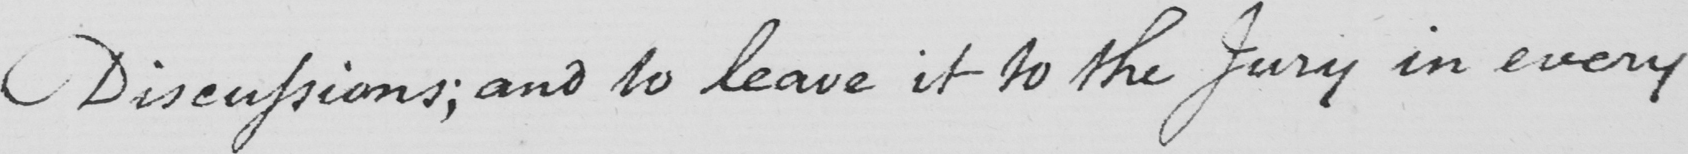Can you tell me what this handwritten text says? Disenssions ; and to leave it to the Jury in every 